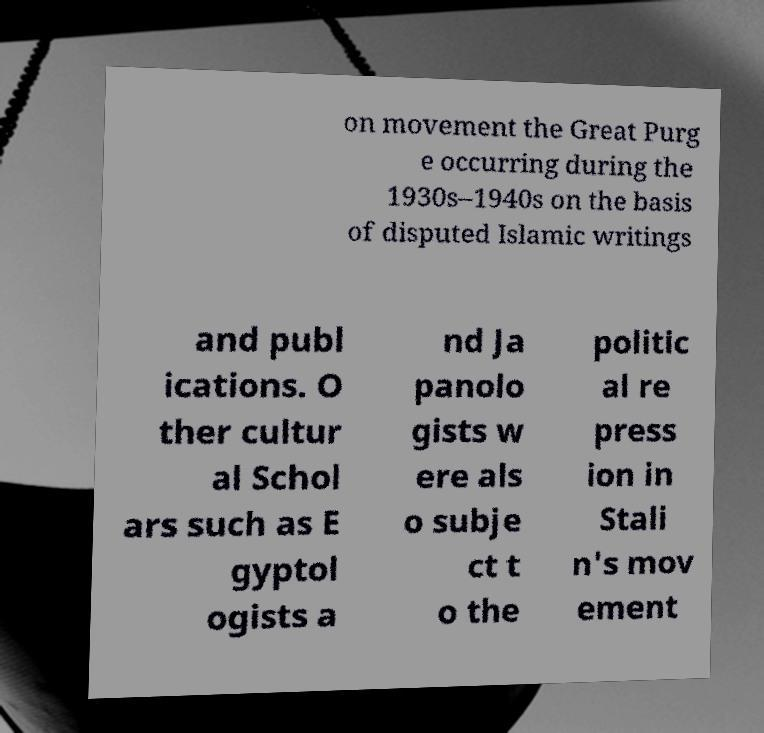Could you extract and type out the text from this image? The text in the image appears cut off and fragmented. What is legible reads: 'on movement the Great Purge occurring during the 1930s-1940s on the basis of disputed Islamic writings and publications. Other cultural scholars such as Egyptologists and Japanologists were also subject to the political repression in Stalin's movement.' This text seems to discuss the political repression during Stalin's regime, specifically mentioning a purge based on Islamic writings and including other fields like Egyptology and Japanology. 